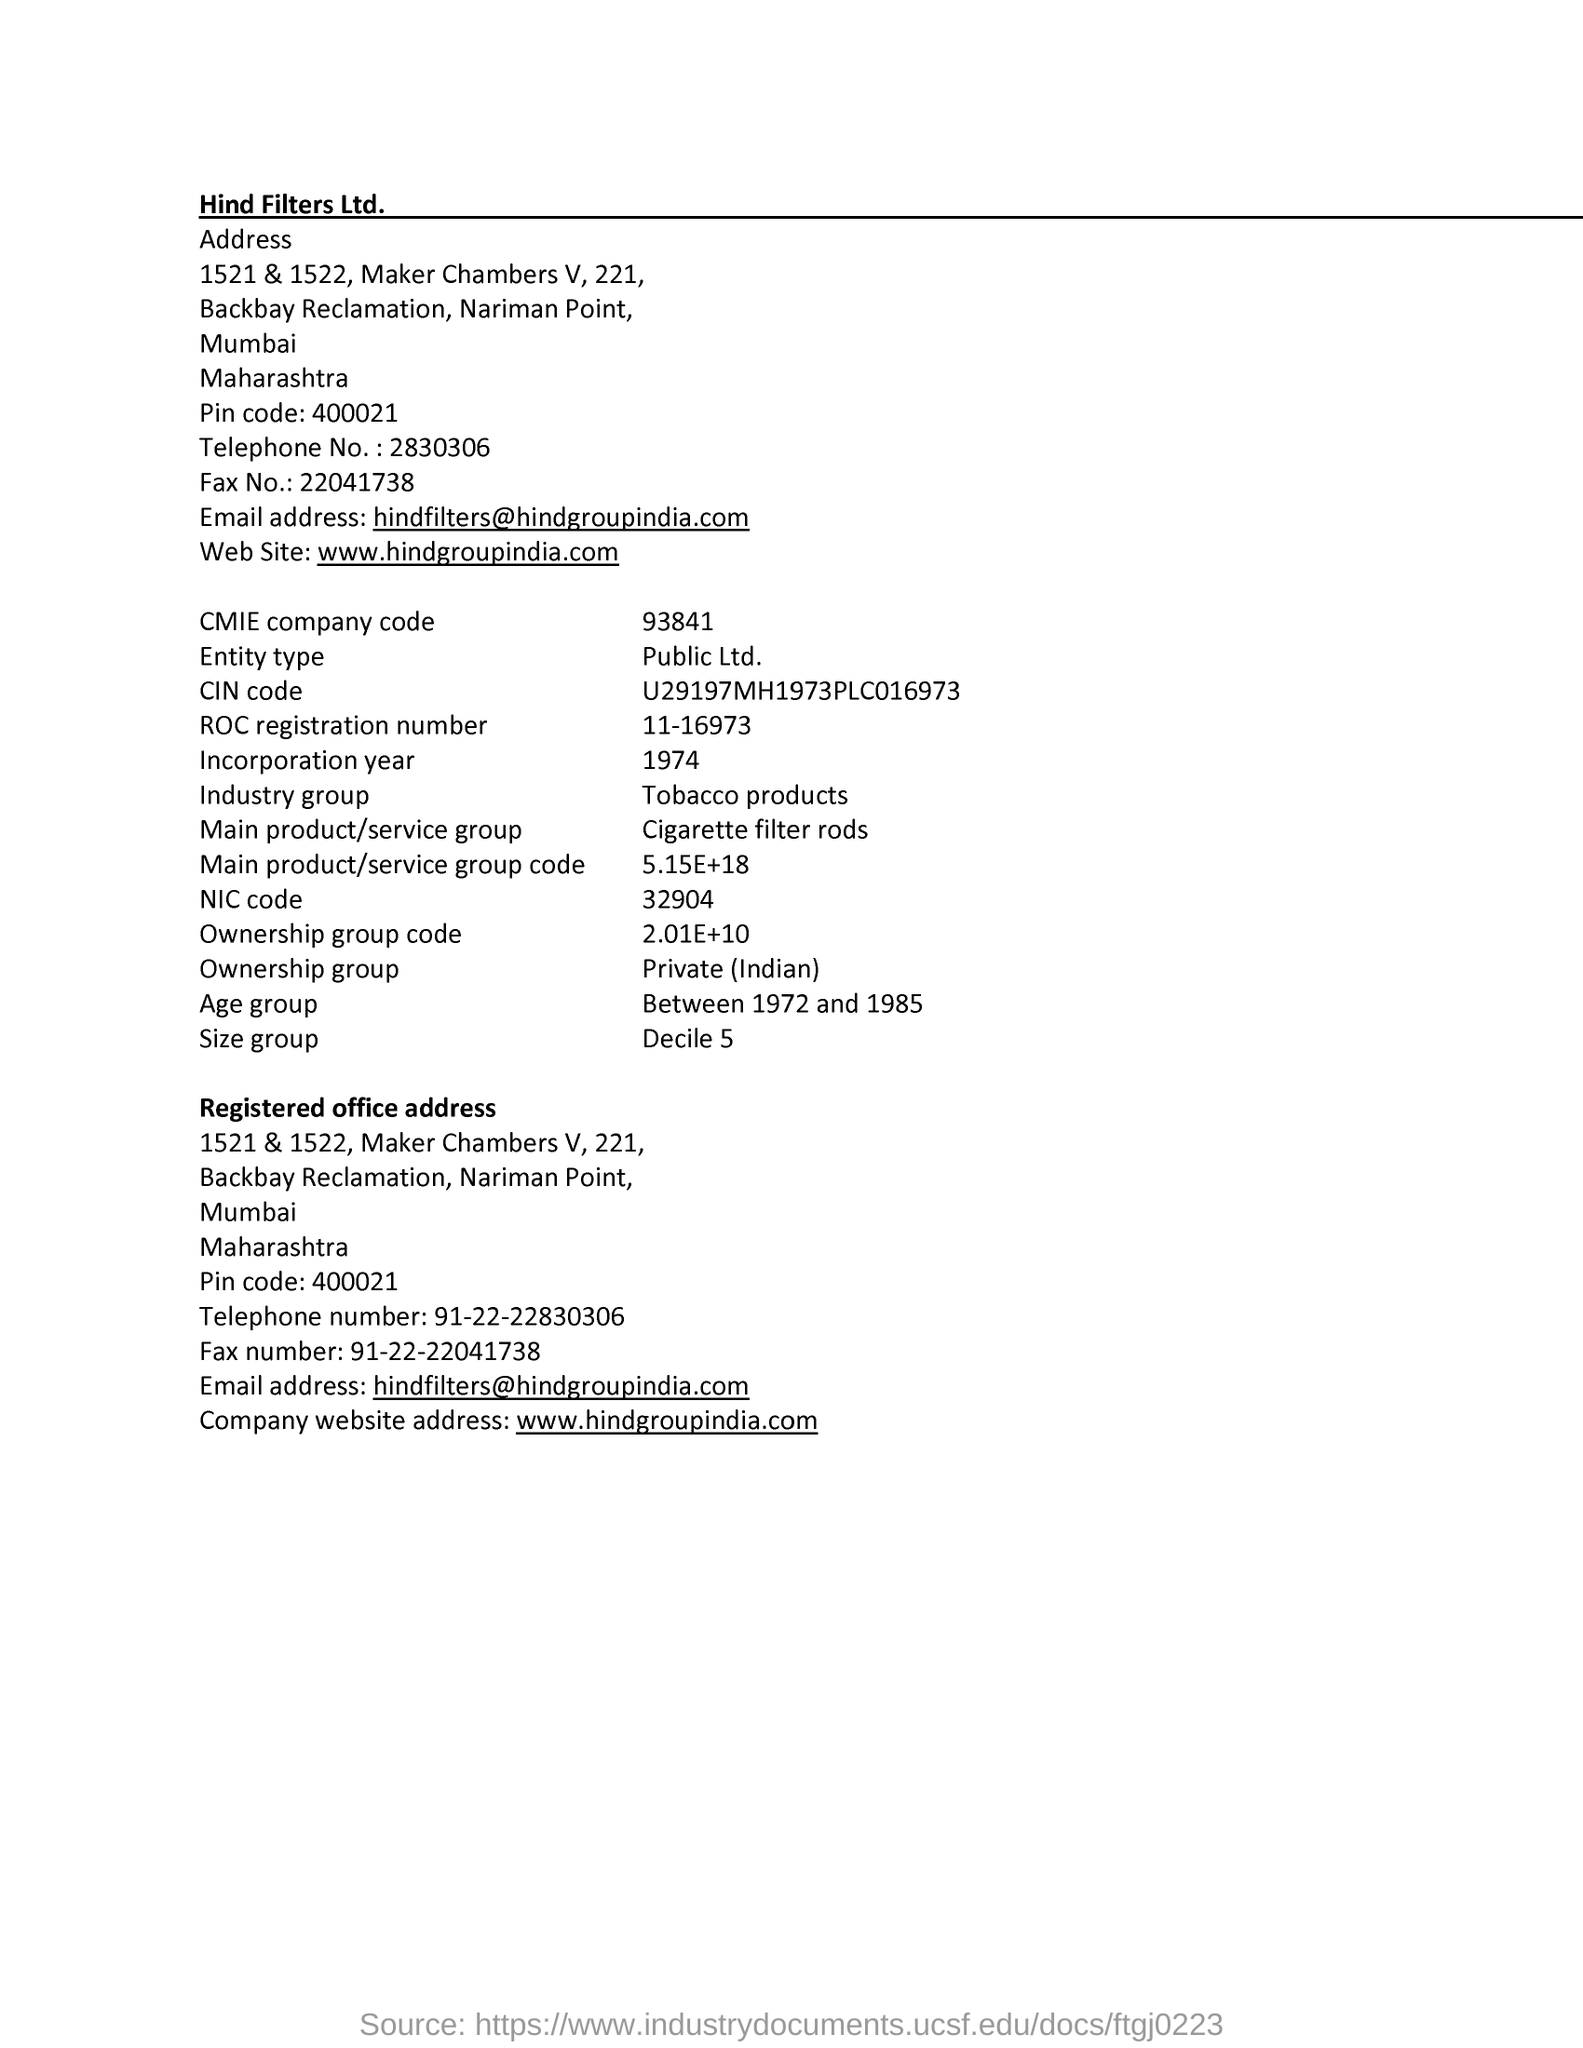What is the telephone no  mentioned in address?
Your answer should be compact. 2830306. What is the fax no mentioned in address ?
Provide a short and direct response. 91-22-22041738. Which state is mentioned in the address
Your answer should be compact. Maharashtra. What is the website mentioned ?
Provide a succinct answer. Www.hindgroupindia.com. What is the email address mentioned ?
Give a very brief answer. Hindfilters@hindgroupindia.com. What is the industry group ?
Keep it short and to the point. Tobacco products. What is the roc registration number ?
Ensure brevity in your answer.  11-16973. What is the entity type ?
Make the answer very short. Public Ltd. 